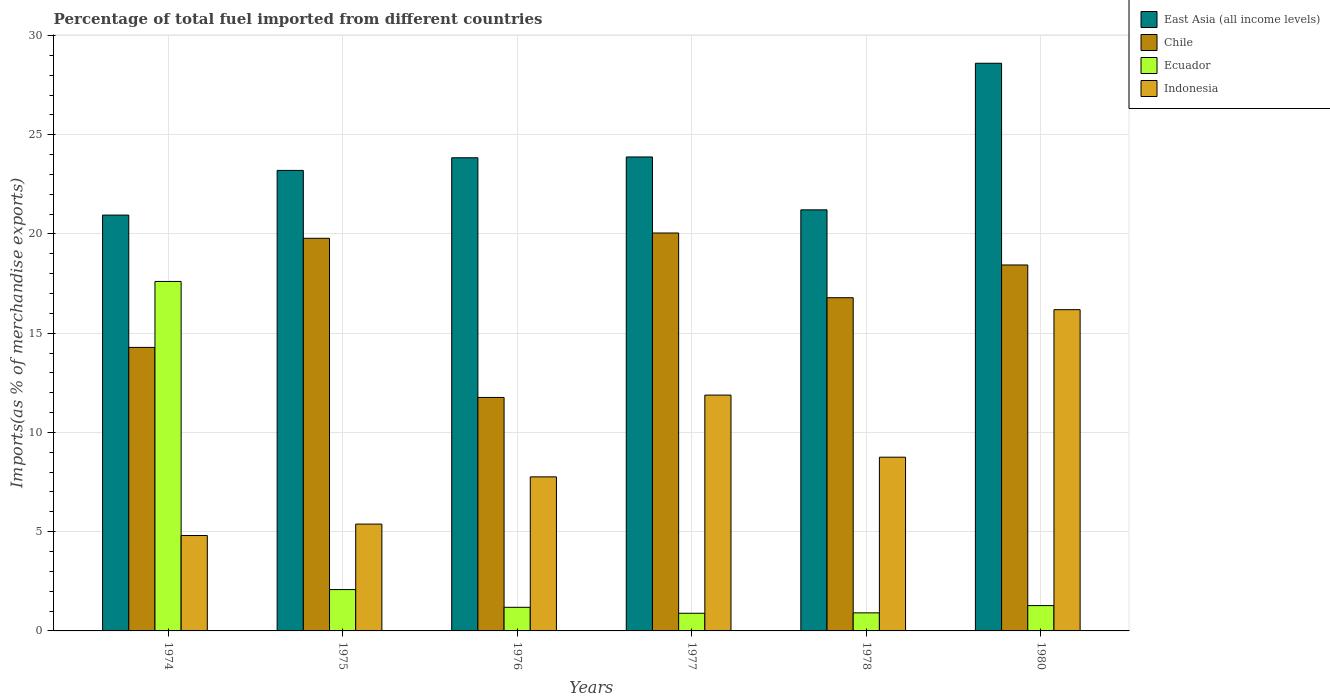How many different coloured bars are there?
Your answer should be compact. 4. Are the number of bars on each tick of the X-axis equal?
Provide a short and direct response. Yes. What is the label of the 2nd group of bars from the left?
Provide a short and direct response. 1975. What is the percentage of imports to different countries in Ecuador in 1975?
Your answer should be very brief. 2.08. Across all years, what is the maximum percentage of imports to different countries in Ecuador?
Provide a short and direct response. 17.61. Across all years, what is the minimum percentage of imports to different countries in Chile?
Your response must be concise. 11.76. What is the total percentage of imports to different countries in Ecuador in the graph?
Keep it short and to the point. 23.96. What is the difference between the percentage of imports to different countries in East Asia (all income levels) in 1975 and that in 1976?
Keep it short and to the point. -0.64. What is the difference between the percentage of imports to different countries in East Asia (all income levels) in 1977 and the percentage of imports to different countries in Chile in 1980?
Your answer should be very brief. 5.44. What is the average percentage of imports to different countries in Ecuador per year?
Your answer should be compact. 3.99. In the year 1978, what is the difference between the percentage of imports to different countries in Indonesia and percentage of imports to different countries in East Asia (all income levels)?
Make the answer very short. -12.46. In how many years, is the percentage of imports to different countries in Indonesia greater than 1 %?
Provide a succinct answer. 6. What is the ratio of the percentage of imports to different countries in Chile in 1976 to that in 1980?
Provide a short and direct response. 0.64. What is the difference between the highest and the second highest percentage of imports to different countries in Indonesia?
Your answer should be compact. 4.3. What is the difference between the highest and the lowest percentage of imports to different countries in Ecuador?
Make the answer very short. 16.72. Is the sum of the percentage of imports to different countries in Chile in 1976 and 1977 greater than the maximum percentage of imports to different countries in Indonesia across all years?
Offer a very short reply. Yes. What does the 2nd bar from the left in 1976 represents?
Ensure brevity in your answer.  Chile. What does the 4th bar from the right in 1976 represents?
Ensure brevity in your answer.  East Asia (all income levels). Are all the bars in the graph horizontal?
Offer a terse response. No. Are the values on the major ticks of Y-axis written in scientific E-notation?
Keep it short and to the point. No. Where does the legend appear in the graph?
Your answer should be very brief. Top right. How are the legend labels stacked?
Your answer should be very brief. Vertical. What is the title of the graph?
Make the answer very short. Percentage of total fuel imported from different countries. What is the label or title of the X-axis?
Your answer should be compact. Years. What is the label or title of the Y-axis?
Your answer should be compact. Imports(as % of merchandise exports). What is the Imports(as % of merchandise exports) of East Asia (all income levels) in 1974?
Give a very brief answer. 20.95. What is the Imports(as % of merchandise exports) in Chile in 1974?
Ensure brevity in your answer.  14.29. What is the Imports(as % of merchandise exports) of Ecuador in 1974?
Provide a short and direct response. 17.61. What is the Imports(as % of merchandise exports) of Indonesia in 1974?
Give a very brief answer. 4.81. What is the Imports(as % of merchandise exports) in East Asia (all income levels) in 1975?
Provide a short and direct response. 23.2. What is the Imports(as % of merchandise exports) of Chile in 1975?
Provide a short and direct response. 19.78. What is the Imports(as % of merchandise exports) of Ecuador in 1975?
Make the answer very short. 2.08. What is the Imports(as % of merchandise exports) in Indonesia in 1975?
Keep it short and to the point. 5.38. What is the Imports(as % of merchandise exports) in East Asia (all income levels) in 1976?
Make the answer very short. 23.84. What is the Imports(as % of merchandise exports) of Chile in 1976?
Ensure brevity in your answer.  11.76. What is the Imports(as % of merchandise exports) in Ecuador in 1976?
Your response must be concise. 1.19. What is the Imports(as % of merchandise exports) of Indonesia in 1976?
Provide a short and direct response. 7.76. What is the Imports(as % of merchandise exports) in East Asia (all income levels) in 1977?
Keep it short and to the point. 23.88. What is the Imports(as % of merchandise exports) in Chile in 1977?
Your answer should be very brief. 20.05. What is the Imports(as % of merchandise exports) of Ecuador in 1977?
Ensure brevity in your answer.  0.89. What is the Imports(as % of merchandise exports) in Indonesia in 1977?
Offer a terse response. 11.88. What is the Imports(as % of merchandise exports) in East Asia (all income levels) in 1978?
Keep it short and to the point. 21.22. What is the Imports(as % of merchandise exports) of Chile in 1978?
Provide a succinct answer. 16.79. What is the Imports(as % of merchandise exports) in Ecuador in 1978?
Your answer should be compact. 0.91. What is the Imports(as % of merchandise exports) of Indonesia in 1978?
Offer a very short reply. 8.75. What is the Imports(as % of merchandise exports) of East Asia (all income levels) in 1980?
Ensure brevity in your answer.  28.6. What is the Imports(as % of merchandise exports) of Chile in 1980?
Offer a terse response. 18.44. What is the Imports(as % of merchandise exports) in Ecuador in 1980?
Provide a succinct answer. 1.28. What is the Imports(as % of merchandise exports) in Indonesia in 1980?
Provide a succinct answer. 16.19. Across all years, what is the maximum Imports(as % of merchandise exports) of East Asia (all income levels)?
Provide a succinct answer. 28.6. Across all years, what is the maximum Imports(as % of merchandise exports) in Chile?
Keep it short and to the point. 20.05. Across all years, what is the maximum Imports(as % of merchandise exports) of Ecuador?
Make the answer very short. 17.61. Across all years, what is the maximum Imports(as % of merchandise exports) of Indonesia?
Offer a very short reply. 16.19. Across all years, what is the minimum Imports(as % of merchandise exports) in East Asia (all income levels)?
Give a very brief answer. 20.95. Across all years, what is the minimum Imports(as % of merchandise exports) in Chile?
Make the answer very short. 11.76. Across all years, what is the minimum Imports(as % of merchandise exports) in Ecuador?
Make the answer very short. 0.89. Across all years, what is the minimum Imports(as % of merchandise exports) in Indonesia?
Keep it short and to the point. 4.81. What is the total Imports(as % of merchandise exports) of East Asia (all income levels) in the graph?
Provide a short and direct response. 141.7. What is the total Imports(as % of merchandise exports) of Chile in the graph?
Keep it short and to the point. 101.11. What is the total Imports(as % of merchandise exports) in Ecuador in the graph?
Your answer should be very brief. 23.96. What is the total Imports(as % of merchandise exports) in Indonesia in the graph?
Your response must be concise. 54.78. What is the difference between the Imports(as % of merchandise exports) in East Asia (all income levels) in 1974 and that in 1975?
Provide a succinct answer. -2.25. What is the difference between the Imports(as % of merchandise exports) of Chile in 1974 and that in 1975?
Make the answer very short. -5.5. What is the difference between the Imports(as % of merchandise exports) in Ecuador in 1974 and that in 1975?
Offer a terse response. 15.53. What is the difference between the Imports(as % of merchandise exports) in Indonesia in 1974 and that in 1975?
Keep it short and to the point. -0.58. What is the difference between the Imports(as % of merchandise exports) in East Asia (all income levels) in 1974 and that in 1976?
Give a very brief answer. -2.89. What is the difference between the Imports(as % of merchandise exports) in Chile in 1974 and that in 1976?
Offer a terse response. 2.52. What is the difference between the Imports(as % of merchandise exports) in Ecuador in 1974 and that in 1976?
Ensure brevity in your answer.  16.42. What is the difference between the Imports(as % of merchandise exports) in Indonesia in 1974 and that in 1976?
Make the answer very short. -2.96. What is the difference between the Imports(as % of merchandise exports) of East Asia (all income levels) in 1974 and that in 1977?
Ensure brevity in your answer.  -2.93. What is the difference between the Imports(as % of merchandise exports) in Chile in 1974 and that in 1977?
Your answer should be compact. -5.76. What is the difference between the Imports(as % of merchandise exports) of Ecuador in 1974 and that in 1977?
Keep it short and to the point. 16.72. What is the difference between the Imports(as % of merchandise exports) of Indonesia in 1974 and that in 1977?
Provide a short and direct response. -7.08. What is the difference between the Imports(as % of merchandise exports) in East Asia (all income levels) in 1974 and that in 1978?
Your response must be concise. -0.26. What is the difference between the Imports(as % of merchandise exports) of Chile in 1974 and that in 1978?
Provide a short and direct response. -2.5. What is the difference between the Imports(as % of merchandise exports) in Ecuador in 1974 and that in 1978?
Your response must be concise. 16.7. What is the difference between the Imports(as % of merchandise exports) in Indonesia in 1974 and that in 1978?
Offer a very short reply. -3.95. What is the difference between the Imports(as % of merchandise exports) of East Asia (all income levels) in 1974 and that in 1980?
Your answer should be compact. -7.65. What is the difference between the Imports(as % of merchandise exports) of Chile in 1974 and that in 1980?
Make the answer very short. -4.15. What is the difference between the Imports(as % of merchandise exports) in Ecuador in 1974 and that in 1980?
Keep it short and to the point. 16.33. What is the difference between the Imports(as % of merchandise exports) of Indonesia in 1974 and that in 1980?
Your answer should be compact. -11.38. What is the difference between the Imports(as % of merchandise exports) in East Asia (all income levels) in 1975 and that in 1976?
Offer a terse response. -0.64. What is the difference between the Imports(as % of merchandise exports) of Chile in 1975 and that in 1976?
Your answer should be compact. 8.02. What is the difference between the Imports(as % of merchandise exports) in Ecuador in 1975 and that in 1976?
Keep it short and to the point. 0.89. What is the difference between the Imports(as % of merchandise exports) in Indonesia in 1975 and that in 1976?
Offer a terse response. -2.38. What is the difference between the Imports(as % of merchandise exports) of East Asia (all income levels) in 1975 and that in 1977?
Your response must be concise. -0.68. What is the difference between the Imports(as % of merchandise exports) of Chile in 1975 and that in 1977?
Your response must be concise. -0.27. What is the difference between the Imports(as % of merchandise exports) of Ecuador in 1975 and that in 1977?
Provide a short and direct response. 1.19. What is the difference between the Imports(as % of merchandise exports) in East Asia (all income levels) in 1975 and that in 1978?
Your response must be concise. 1.99. What is the difference between the Imports(as % of merchandise exports) of Chile in 1975 and that in 1978?
Your response must be concise. 2.99. What is the difference between the Imports(as % of merchandise exports) of Ecuador in 1975 and that in 1978?
Keep it short and to the point. 1.17. What is the difference between the Imports(as % of merchandise exports) in Indonesia in 1975 and that in 1978?
Keep it short and to the point. -3.37. What is the difference between the Imports(as % of merchandise exports) in East Asia (all income levels) in 1975 and that in 1980?
Offer a very short reply. -5.4. What is the difference between the Imports(as % of merchandise exports) of Chile in 1975 and that in 1980?
Your response must be concise. 1.34. What is the difference between the Imports(as % of merchandise exports) in Ecuador in 1975 and that in 1980?
Provide a succinct answer. 0.81. What is the difference between the Imports(as % of merchandise exports) of Indonesia in 1975 and that in 1980?
Keep it short and to the point. -10.8. What is the difference between the Imports(as % of merchandise exports) of East Asia (all income levels) in 1976 and that in 1977?
Provide a succinct answer. -0.04. What is the difference between the Imports(as % of merchandise exports) in Chile in 1976 and that in 1977?
Keep it short and to the point. -8.29. What is the difference between the Imports(as % of merchandise exports) in Ecuador in 1976 and that in 1977?
Offer a terse response. 0.3. What is the difference between the Imports(as % of merchandise exports) in Indonesia in 1976 and that in 1977?
Your answer should be compact. -4.12. What is the difference between the Imports(as % of merchandise exports) in East Asia (all income levels) in 1976 and that in 1978?
Your response must be concise. 2.62. What is the difference between the Imports(as % of merchandise exports) in Chile in 1976 and that in 1978?
Keep it short and to the point. -5.03. What is the difference between the Imports(as % of merchandise exports) in Ecuador in 1976 and that in 1978?
Keep it short and to the point. 0.28. What is the difference between the Imports(as % of merchandise exports) of Indonesia in 1976 and that in 1978?
Your response must be concise. -0.99. What is the difference between the Imports(as % of merchandise exports) of East Asia (all income levels) in 1976 and that in 1980?
Offer a very short reply. -4.76. What is the difference between the Imports(as % of merchandise exports) of Chile in 1976 and that in 1980?
Provide a short and direct response. -6.67. What is the difference between the Imports(as % of merchandise exports) in Ecuador in 1976 and that in 1980?
Your answer should be compact. -0.09. What is the difference between the Imports(as % of merchandise exports) of Indonesia in 1976 and that in 1980?
Offer a terse response. -8.42. What is the difference between the Imports(as % of merchandise exports) of East Asia (all income levels) in 1977 and that in 1978?
Your response must be concise. 2.67. What is the difference between the Imports(as % of merchandise exports) in Chile in 1977 and that in 1978?
Your answer should be very brief. 3.26. What is the difference between the Imports(as % of merchandise exports) of Ecuador in 1977 and that in 1978?
Your answer should be compact. -0.02. What is the difference between the Imports(as % of merchandise exports) in Indonesia in 1977 and that in 1978?
Offer a terse response. 3.13. What is the difference between the Imports(as % of merchandise exports) of East Asia (all income levels) in 1977 and that in 1980?
Offer a very short reply. -4.72. What is the difference between the Imports(as % of merchandise exports) of Chile in 1977 and that in 1980?
Offer a very short reply. 1.61. What is the difference between the Imports(as % of merchandise exports) of Ecuador in 1977 and that in 1980?
Provide a succinct answer. -0.39. What is the difference between the Imports(as % of merchandise exports) in Indonesia in 1977 and that in 1980?
Make the answer very short. -4.3. What is the difference between the Imports(as % of merchandise exports) in East Asia (all income levels) in 1978 and that in 1980?
Offer a terse response. -7.39. What is the difference between the Imports(as % of merchandise exports) in Chile in 1978 and that in 1980?
Give a very brief answer. -1.65. What is the difference between the Imports(as % of merchandise exports) of Ecuador in 1978 and that in 1980?
Provide a short and direct response. -0.37. What is the difference between the Imports(as % of merchandise exports) of Indonesia in 1978 and that in 1980?
Your answer should be very brief. -7.43. What is the difference between the Imports(as % of merchandise exports) in East Asia (all income levels) in 1974 and the Imports(as % of merchandise exports) in Chile in 1975?
Give a very brief answer. 1.17. What is the difference between the Imports(as % of merchandise exports) of East Asia (all income levels) in 1974 and the Imports(as % of merchandise exports) of Ecuador in 1975?
Make the answer very short. 18.87. What is the difference between the Imports(as % of merchandise exports) in East Asia (all income levels) in 1974 and the Imports(as % of merchandise exports) in Indonesia in 1975?
Keep it short and to the point. 15.57. What is the difference between the Imports(as % of merchandise exports) of Chile in 1974 and the Imports(as % of merchandise exports) of Ecuador in 1975?
Keep it short and to the point. 12.2. What is the difference between the Imports(as % of merchandise exports) of Chile in 1974 and the Imports(as % of merchandise exports) of Indonesia in 1975?
Your answer should be compact. 8.9. What is the difference between the Imports(as % of merchandise exports) of Ecuador in 1974 and the Imports(as % of merchandise exports) of Indonesia in 1975?
Your answer should be very brief. 12.23. What is the difference between the Imports(as % of merchandise exports) of East Asia (all income levels) in 1974 and the Imports(as % of merchandise exports) of Chile in 1976?
Ensure brevity in your answer.  9.19. What is the difference between the Imports(as % of merchandise exports) of East Asia (all income levels) in 1974 and the Imports(as % of merchandise exports) of Ecuador in 1976?
Make the answer very short. 19.76. What is the difference between the Imports(as % of merchandise exports) in East Asia (all income levels) in 1974 and the Imports(as % of merchandise exports) in Indonesia in 1976?
Offer a very short reply. 13.19. What is the difference between the Imports(as % of merchandise exports) in Chile in 1974 and the Imports(as % of merchandise exports) in Ecuador in 1976?
Your response must be concise. 13.1. What is the difference between the Imports(as % of merchandise exports) of Chile in 1974 and the Imports(as % of merchandise exports) of Indonesia in 1976?
Provide a succinct answer. 6.52. What is the difference between the Imports(as % of merchandise exports) in Ecuador in 1974 and the Imports(as % of merchandise exports) in Indonesia in 1976?
Provide a short and direct response. 9.85. What is the difference between the Imports(as % of merchandise exports) of East Asia (all income levels) in 1974 and the Imports(as % of merchandise exports) of Chile in 1977?
Give a very brief answer. 0.9. What is the difference between the Imports(as % of merchandise exports) in East Asia (all income levels) in 1974 and the Imports(as % of merchandise exports) in Ecuador in 1977?
Offer a terse response. 20.06. What is the difference between the Imports(as % of merchandise exports) of East Asia (all income levels) in 1974 and the Imports(as % of merchandise exports) of Indonesia in 1977?
Give a very brief answer. 9.07. What is the difference between the Imports(as % of merchandise exports) of Chile in 1974 and the Imports(as % of merchandise exports) of Ecuador in 1977?
Offer a very short reply. 13.4. What is the difference between the Imports(as % of merchandise exports) in Chile in 1974 and the Imports(as % of merchandise exports) in Indonesia in 1977?
Your response must be concise. 2.4. What is the difference between the Imports(as % of merchandise exports) of Ecuador in 1974 and the Imports(as % of merchandise exports) of Indonesia in 1977?
Give a very brief answer. 5.73. What is the difference between the Imports(as % of merchandise exports) of East Asia (all income levels) in 1974 and the Imports(as % of merchandise exports) of Chile in 1978?
Keep it short and to the point. 4.16. What is the difference between the Imports(as % of merchandise exports) in East Asia (all income levels) in 1974 and the Imports(as % of merchandise exports) in Ecuador in 1978?
Keep it short and to the point. 20.04. What is the difference between the Imports(as % of merchandise exports) of East Asia (all income levels) in 1974 and the Imports(as % of merchandise exports) of Indonesia in 1978?
Provide a short and direct response. 12.2. What is the difference between the Imports(as % of merchandise exports) in Chile in 1974 and the Imports(as % of merchandise exports) in Ecuador in 1978?
Ensure brevity in your answer.  13.38. What is the difference between the Imports(as % of merchandise exports) of Chile in 1974 and the Imports(as % of merchandise exports) of Indonesia in 1978?
Ensure brevity in your answer.  5.53. What is the difference between the Imports(as % of merchandise exports) in Ecuador in 1974 and the Imports(as % of merchandise exports) in Indonesia in 1978?
Provide a short and direct response. 8.86. What is the difference between the Imports(as % of merchandise exports) in East Asia (all income levels) in 1974 and the Imports(as % of merchandise exports) in Chile in 1980?
Your response must be concise. 2.51. What is the difference between the Imports(as % of merchandise exports) of East Asia (all income levels) in 1974 and the Imports(as % of merchandise exports) of Ecuador in 1980?
Ensure brevity in your answer.  19.68. What is the difference between the Imports(as % of merchandise exports) in East Asia (all income levels) in 1974 and the Imports(as % of merchandise exports) in Indonesia in 1980?
Your answer should be very brief. 4.77. What is the difference between the Imports(as % of merchandise exports) in Chile in 1974 and the Imports(as % of merchandise exports) in Ecuador in 1980?
Offer a very short reply. 13.01. What is the difference between the Imports(as % of merchandise exports) in Chile in 1974 and the Imports(as % of merchandise exports) in Indonesia in 1980?
Your answer should be compact. -1.9. What is the difference between the Imports(as % of merchandise exports) in Ecuador in 1974 and the Imports(as % of merchandise exports) in Indonesia in 1980?
Your answer should be very brief. 1.42. What is the difference between the Imports(as % of merchandise exports) in East Asia (all income levels) in 1975 and the Imports(as % of merchandise exports) in Chile in 1976?
Keep it short and to the point. 11.44. What is the difference between the Imports(as % of merchandise exports) of East Asia (all income levels) in 1975 and the Imports(as % of merchandise exports) of Ecuador in 1976?
Offer a terse response. 22.01. What is the difference between the Imports(as % of merchandise exports) of East Asia (all income levels) in 1975 and the Imports(as % of merchandise exports) of Indonesia in 1976?
Make the answer very short. 15.44. What is the difference between the Imports(as % of merchandise exports) in Chile in 1975 and the Imports(as % of merchandise exports) in Ecuador in 1976?
Give a very brief answer. 18.59. What is the difference between the Imports(as % of merchandise exports) in Chile in 1975 and the Imports(as % of merchandise exports) in Indonesia in 1976?
Offer a terse response. 12.02. What is the difference between the Imports(as % of merchandise exports) in Ecuador in 1975 and the Imports(as % of merchandise exports) in Indonesia in 1976?
Give a very brief answer. -5.68. What is the difference between the Imports(as % of merchandise exports) in East Asia (all income levels) in 1975 and the Imports(as % of merchandise exports) in Chile in 1977?
Offer a very short reply. 3.15. What is the difference between the Imports(as % of merchandise exports) in East Asia (all income levels) in 1975 and the Imports(as % of merchandise exports) in Ecuador in 1977?
Offer a very short reply. 22.31. What is the difference between the Imports(as % of merchandise exports) in East Asia (all income levels) in 1975 and the Imports(as % of merchandise exports) in Indonesia in 1977?
Your answer should be compact. 11.32. What is the difference between the Imports(as % of merchandise exports) of Chile in 1975 and the Imports(as % of merchandise exports) of Ecuador in 1977?
Give a very brief answer. 18.89. What is the difference between the Imports(as % of merchandise exports) in Chile in 1975 and the Imports(as % of merchandise exports) in Indonesia in 1977?
Your answer should be compact. 7.9. What is the difference between the Imports(as % of merchandise exports) in Ecuador in 1975 and the Imports(as % of merchandise exports) in Indonesia in 1977?
Provide a succinct answer. -9.8. What is the difference between the Imports(as % of merchandise exports) in East Asia (all income levels) in 1975 and the Imports(as % of merchandise exports) in Chile in 1978?
Ensure brevity in your answer.  6.41. What is the difference between the Imports(as % of merchandise exports) of East Asia (all income levels) in 1975 and the Imports(as % of merchandise exports) of Ecuador in 1978?
Your answer should be very brief. 22.29. What is the difference between the Imports(as % of merchandise exports) of East Asia (all income levels) in 1975 and the Imports(as % of merchandise exports) of Indonesia in 1978?
Ensure brevity in your answer.  14.45. What is the difference between the Imports(as % of merchandise exports) of Chile in 1975 and the Imports(as % of merchandise exports) of Ecuador in 1978?
Provide a succinct answer. 18.87. What is the difference between the Imports(as % of merchandise exports) in Chile in 1975 and the Imports(as % of merchandise exports) in Indonesia in 1978?
Offer a very short reply. 11.03. What is the difference between the Imports(as % of merchandise exports) of Ecuador in 1975 and the Imports(as % of merchandise exports) of Indonesia in 1978?
Offer a terse response. -6.67. What is the difference between the Imports(as % of merchandise exports) of East Asia (all income levels) in 1975 and the Imports(as % of merchandise exports) of Chile in 1980?
Offer a very short reply. 4.76. What is the difference between the Imports(as % of merchandise exports) in East Asia (all income levels) in 1975 and the Imports(as % of merchandise exports) in Ecuador in 1980?
Keep it short and to the point. 21.93. What is the difference between the Imports(as % of merchandise exports) in East Asia (all income levels) in 1975 and the Imports(as % of merchandise exports) in Indonesia in 1980?
Offer a very short reply. 7.02. What is the difference between the Imports(as % of merchandise exports) of Chile in 1975 and the Imports(as % of merchandise exports) of Ecuador in 1980?
Your answer should be very brief. 18.51. What is the difference between the Imports(as % of merchandise exports) in Chile in 1975 and the Imports(as % of merchandise exports) in Indonesia in 1980?
Offer a terse response. 3.6. What is the difference between the Imports(as % of merchandise exports) of Ecuador in 1975 and the Imports(as % of merchandise exports) of Indonesia in 1980?
Give a very brief answer. -14.1. What is the difference between the Imports(as % of merchandise exports) in East Asia (all income levels) in 1976 and the Imports(as % of merchandise exports) in Chile in 1977?
Provide a short and direct response. 3.79. What is the difference between the Imports(as % of merchandise exports) of East Asia (all income levels) in 1976 and the Imports(as % of merchandise exports) of Ecuador in 1977?
Provide a short and direct response. 22.95. What is the difference between the Imports(as % of merchandise exports) in East Asia (all income levels) in 1976 and the Imports(as % of merchandise exports) in Indonesia in 1977?
Give a very brief answer. 11.96. What is the difference between the Imports(as % of merchandise exports) of Chile in 1976 and the Imports(as % of merchandise exports) of Ecuador in 1977?
Your response must be concise. 10.87. What is the difference between the Imports(as % of merchandise exports) of Chile in 1976 and the Imports(as % of merchandise exports) of Indonesia in 1977?
Keep it short and to the point. -0.12. What is the difference between the Imports(as % of merchandise exports) in Ecuador in 1976 and the Imports(as % of merchandise exports) in Indonesia in 1977?
Provide a succinct answer. -10.69. What is the difference between the Imports(as % of merchandise exports) in East Asia (all income levels) in 1976 and the Imports(as % of merchandise exports) in Chile in 1978?
Your answer should be very brief. 7.05. What is the difference between the Imports(as % of merchandise exports) in East Asia (all income levels) in 1976 and the Imports(as % of merchandise exports) in Ecuador in 1978?
Provide a short and direct response. 22.93. What is the difference between the Imports(as % of merchandise exports) of East Asia (all income levels) in 1976 and the Imports(as % of merchandise exports) of Indonesia in 1978?
Your answer should be compact. 15.09. What is the difference between the Imports(as % of merchandise exports) in Chile in 1976 and the Imports(as % of merchandise exports) in Ecuador in 1978?
Give a very brief answer. 10.85. What is the difference between the Imports(as % of merchandise exports) in Chile in 1976 and the Imports(as % of merchandise exports) in Indonesia in 1978?
Offer a terse response. 3.01. What is the difference between the Imports(as % of merchandise exports) in Ecuador in 1976 and the Imports(as % of merchandise exports) in Indonesia in 1978?
Keep it short and to the point. -7.56. What is the difference between the Imports(as % of merchandise exports) of East Asia (all income levels) in 1976 and the Imports(as % of merchandise exports) of Chile in 1980?
Keep it short and to the point. 5.4. What is the difference between the Imports(as % of merchandise exports) in East Asia (all income levels) in 1976 and the Imports(as % of merchandise exports) in Ecuador in 1980?
Keep it short and to the point. 22.56. What is the difference between the Imports(as % of merchandise exports) of East Asia (all income levels) in 1976 and the Imports(as % of merchandise exports) of Indonesia in 1980?
Your response must be concise. 7.65. What is the difference between the Imports(as % of merchandise exports) in Chile in 1976 and the Imports(as % of merchandise exports) in Ecuador in 1980?
Offer a terse response. 10.49. What is the difference between the Imports(as % of merchandise exports) in Chile in 1976 and the Imports(as % of merchandise exports) in Indonesia in 1980?
Provide a succinct answer. -4.42. What is the difference between the Imports(as % of merchandise exports) of Ecuador in 1976 and the Imports(as % of merchandise exports) of Indonesia in 1980?
Ensure brevity in your answer.  -15. What is the difference between the Imports(as % of merchandise exports) in East Asia (all income levels) in 1977 and the Imports(as % of merchandise exports) in Chile in 1978?
Provide a succinct answer. 7.09. What is the difference between the Imports(as % of merchandise exports) in East Asia (all income levels) in 1977 and the Imports(as % of merchandise exports) in Ecuador in 1978?
Provide a succinct answer. 22.97. What is the difference between the Imports(as % of merchandise exports) in East Asia (all income levels) in 1977 and the Imports(as % of merchandise exports) in Indonesia in 1978?
Provide a short and direct response. 15.13. What is the difference between the Imports(as % of merchandise exports) of Chile in 1977 and the Imports(as % of merchandise exports) of Ecuador in 1978?
Offer a very short reply. 19.14. What is the difference between the Imports(as % of merchandise exports) of Chile in 1977 and the Imports(as % of merchandise exports) of Indonesia in 1978?
Your answer should be compact. 11.3. What is the difference between the Imports(as % of merchandise exports) in Ecuador in 1977 and the Imports(as % of merchandise exports) in Indonesia in 1978?
Make the answer very short. -7.86. What is the difference between the Imports(as % of merchandise exports) in East Asia (all income levels) in 1977 and the Imports(as % of merchandise exports) in Chile in 1980?
Your answer should be very brief. 5.44. What is the difference between the Imports(as % of merchandise exports) of East Asia (all income levels) in 1977 and the Imports(as % of merchandise exports) of Ecuador in 1980?
Your response must be concise. 22.61. What is the difference between the Imports(as % of merchandise exports) of East Asia (all income levels) in 1977 and the Imports(as % of merchandise exports) of Indonesia in 1980?
Provide a succinct answer. 7.69. What is the difference between the Imports(as % of merchandise exports) of Chile in 1977 and the Imports(as % of merchandise exports) of Ecuador in 1980?
Provide a short and direct response. 18.77. What is the difference between the Imports(as % of merchandise exports) in Chile in 1977 and the Imports(as % of merchandise exports) in Indonesia in 1980?
Make the answer very short. 3.86. What is the difference between the Imports(as % of merchandise exports) in Ecuador in 1977 and the Imports(as % of merchandise exports) in Indonesia in 1980?
Ensure brevity in your answer.  -15.3. What is the difference between the Imports(as % of merchandise exports) in East Asia (all income levels) in 1978 and the Imports(as % of merchandise exports) in Chile in 1980?
Offer a terse response. 2.78. What is the difference between the Imports(as % of merchandise exports) in East Asia (all income levels) in 1978 and the Imports(as % of merchandise exports) in Ecuador in 1980?
Provide a succinct answer. 19.94. What is the difference between the Imports(as % of merchandise exports) of East Asia (all income levels) in 1978 and the Imports(as % of merchandise exports) of Indonesia in 1980?
Your answer should be very brief. 5.03. What is the difference between the Imports(as % of merchandise exports) of Chile in 1978 and the Imports(as % of merchandise exports) of Ecuador in 1980?
Provide a succinct answer. 15.51. What is the difference between the Imports(as % of merchandise exports) in Chile in 1978 and the Imports(as % of merchandise exports) in Indonesia in 1980?
Your response must be concise. 0.6. What is the difference between the Imports(as % of merchandise exports) of Ecuador in 1978 and the Imports(as % of merchandise exports) of Indonesia in 1980?
Offer a terse response. -15.28. What is the average Imports(as % of merchandise exports) in East Asia (all income levels) per year?
Your response must be concise. 23.62. What is the average Imports(as % of merchandise exports) of Chile per year?
Give a very brief answer. 16.85. What is the average Imports(as % of merchandise exports) in Ecuador per year?
Your answer should be very brief. 3.99. What is the average Imports(as % of merchandise exports) of Indonesia per year?
Your answer should be compact. 9.13. In the year 1974, what is the difference between the Imports(as % of merchandise exports) in East Asia (all income levels) and Imports(as % of merchandise exports) in Chile?
Provide a short and direct response. 6.67. In the year 1974, what is the difference between the Imports(as % of merchandise exports) of East Asia (all income levels) and Imports(as % of merchandise exports) of Ecuador?
Ensure brevity in your answer.  3.34. In the year 1974, what is the difference between the Imports(as % of merchandise exports) in East Asia (all income levels) and Imports(as % of merchandise exports) in Indonesia?
Your response must be concise. 16.15. In the year 1974, what is the difference between the Imports(as % of merchandise exports) in Chile and Imports(as % of merchandise exports) in Ecuador?
Offer a terse response. -3.32. In the year 1974, what is the difference between the Imports(as % of merchandise exports) of Chile and Imports(as % of merchandise exports) of Indonesia?
Your answer should be compact. 9.48. In the year 1974, what is the difference between the Imports(as % of merchandise exports) in Ecuador and Imports(as % of merchandise exports) in Indonesia?
Give a very brief answer. 12.8. In the year 1975, what is the difference between the Imports(as % of merchandise exports) in East Asia (all income levels) and Imports(as % of merchandise exports) in Chile?
Your response must be concise. 3.42. In the year 1975, what is the difference between the Imports(as % of merchandise exports) of East Asia (all income levels) and Imports(as % of merchandise exports) of Ecuador?
Offer a very short reply. 21.12. In the year 1975, what is the difference between the Imports(as % of merchandise exports) in East Asia (all income levels) and Imports(as % of merchandise exports) in Indonesia?
Your answer should be compact. 17.82. In the year 1975, what is the difference between the Imports(as % of merchandise exports) of Chile and Imports(as % of merchandise exports) of Ecuador?
Offer a terse response. 17.7. In the year 1975, what is the difference between the Imports(as % of merchandise exports) in Chile and Imports(as % of merchandise exports) in Indonesia?
Keep it short and to the point. 14.4. In the year 1975, what is the difference between the Imports(as % of merchandise exports) of Ecuador and Imports(as % of merchandise exports) of Indonesia?
Your response must be concise. -3.3. In the year 1976, what is the difference between the Imports(as % of merchandise exports) of East Asia (all income levels) and Imports(as % of merchandise exports) of Chile?
Ensure brevity in your answer.  12.08. In the year 1976, what is the difference between the Imports(as % of merchandise exports) in East Asia (all income levels) and Imports(as % of merchandise exports) in Ecuador?
Offer a very short reply. 22.65. In the year 1976, what is the difference between the Imports(as % of merchandise exports) in East Asia (all income levels) and Imports(as % of merchandise exports) in Indonesia?
Provide a short and direct response. 16.08. In the year 1976, what is the difference between the Imports(as % of merchandise exports) of Chile and Imports(as % of merchandise exports) of Ecuador?
Keep it short and to the point. 10.57. In the year 1976, what is the difference between the Imports(as % of merchandise exports) of Chile and Imports(as % of merchandise exports) of Indonesia?
Keep it short and to the point. 4. In the year 1976, what is the difference between the Imports(as % of merchandise exports) of Ecuador and Imports(as % of merchandise exports) of Indonesia?
Provide a succinct answer. -6.57. In the year 1977, what is the difference between the Imports(as % of merchandise exports) of East Asia (all income levels) and Imports(as % of merchandise exports) of Chile?
Provide a short and direct response. 3.83. In the year 1977, what is the difference between the Imports(as % of merchandise exports) in East Asia (all income levels) and Imports(as % of merchandise exports) in Ecuador?
Your response must be concise. 22.99. In the year 1977, what is the difference between the Imports(as % of merchandise exports) of East Asia (all income levels) and Imports(as % of merchandise exports) of Indonesia?
Offer a very short reply. 12. In the year 1977, what is the difference between the Imports(as % of merchandise exports) in Chile and Imports(as % of merchandise exports) in Ecuador?
Ensure brevity in your answer.  19.16. In the year 1977, what is the difference between the Imports(as % of merchandise exports) of Chile and Imports(as % of merchandise exports) of Indonesia?
Keep it short and to the point. 8.17. In the year 1977, what is the difference between the Imports(as % of merchandise exports) of Ecuador and Imports(as % of merchandise exports) of Indonesia?
Your answer should be compact. -10.99. In the year 1978, what is the difference between the Imports(as % of merchandise exports) in East Asia (all income levels) and Imports(as % of merchandise exports) in Chile?
Make the answer very short. 4.43. In the year 1978, what is the difference between the Imports(as % of merchandise exports) of East Asia (all income levels) and Imports(as % of merchandise exports) of Ecuador?
Your response must be concise. 20.31. In the year 1978, what is the difference between the Imports(as % of merchandise exports) in East Asia (all income levels) and Imports(as % of merchandise exports) in Indonesia?
Keep it short and to the point. 12.46. In the year 1978, what is the difference between the Imports(as % of merchandise exports) of Chile and Imports(as % of merchandise exports) of Ecuador?
Give a very brief answer. 15.88. In the year 1978, what is the difference between the Imports(as % of merchandise exports) of Chile and Imports(as % of merchandise exports) of Indonesia?
Make the answer very short. 8.04. In the year 1978, what is the difference between the Imports(as % of merchandise exports) of Ecuador and Imports(as % of merchandise exports) of Indonesia?
Your answer should be compact. -7.84. In the year 1980, what is the difference between the Imports(as % of merchandise exports) of East Asia (all income levels) and Imports(as % of merchandise exports) of Chile?
Make the answer very short. 10.16. In the year 1980, what is the difference between the Imports(as % of merchandise exports) in East Asia (all income levels) and Imports(as % of merchandise exports) in Ecuador?
Provide a succinct answer. 27.33. In the year 1980, what is the difference between the Imports(as % of merchandise exports) of East Asia (all income levels) and Imports(as % of merchandise exports) of Indonesia?
Your answer should be very brief. 12.42. In the year 1980, what is the difference between the Imports(as % of merchandise exports) of Chile and Imports(as % of merchandise exports) of Ecuador?
Offer a terse response. 17.16. In the year 1980, what is the difference between the Imports(as % of merchandise exports) in Chile and Imports(as % of merchandise exports) in Indonesia?
Provide a succinct answer. 2.25. In the year 1980, what is the difference between the Imports(as % of merchandise exports) of Ecuador and Imports(as % of merchandise exports) of Indonesia?
Your answer should be very brief. -14.91. What is the ratio of the Imports(as % of merchandise exports) in East Asia (all income levels) in 1974 to that in 1975?
Offer a very short reply. 0.9. What is the ratio of the Imports(as % of merchandise exports) of Chile in 1974 to that in 1975?
Make the answer very short. 0.72. What is the ratio of the Imports(as % of merchandise exports) of Ecuador in 1974 to that in 1975?
Provide a short and direct response. 8.45. What is the ratio of the Imports(as % of merchandise exports) in Indonesia in 1974 to that in 1975?
Offer a terse response. 0.89. What is the ratio of the Imports(as % of merchandise exports) in East Asia (all income levels) in 1974 to that in 1976?
Your answer should be compact. 0.88. What is the ratio of the Imports(as % of merchandise exports) in Chile in 1974 to that in 1976?
Ensure brevity in your answer.  1.21. What is the ratio of the Imports(as % of merchandise exports) in Ecuador in 1974 to that in 1976?
Offer a terse response. 14.8. What is the ratio of the Imports(as % of merchandise exports) in Indonesia in 1974 to that in 1976?
Your answer should be very brief. 0.62. What is the ratio of the Imports(as % of merchandise exports) of East Asia (all income levels) in 1974 to that in 1977?
Your response must be concise. 0.88. What is the ratio of the Imports(as % of merchandise exports) in Chile in 1974 to that in 1977?
Offer a terse response. 0.71. What is the ratio of the Imports(as % of merchandise exports) of Ecuador in 1974 to that in 1977?
Provide a short and direct response. 19.79. What is the ratio of the Imports(as % of merchandise exports) of Indonesia in 1974 to that in 1977?
Provide a short and direct response. 0.4. What is the ratio of the Imports(as % of merchandise exports) in East Asia (all income levels) in 1974 to that in 1978?
Your answer should be very brief. 0.99. What is the ratio of the Imports(as % of merchandise exports) of Chile in 1974 to that in 1978?
Your answer should be compact. 0.85. What is the ratio of the Imports(as % of merchandise exports) in Ecuador in 1974 to that in 1978?
Your response must be concise. 19.34. What is the ratio of the Imports(as % of merchandise exports) in Indonesia in 1974 to that in 1978?
Give a very brief answer. 0.55. What is the ratio of the Imports(as % of merchandise exports) in East Asia (all income levels) in 1974 to that in 1980?
Ensure brevity in your answer.  0.73. What is the ratio of the Imports(as % of merchandise exports) of Chile in 1974 to that in 1980?
Make the answer very short. 0.77. What is the ratio of the Imports(as % of merchandise exports) in Ecuador in 1974 to that in 1980?
Offer a terse response. 13.79. What is the ratio of the Imports(as % of merchandise exports) in Indonesia in 1974 to that in 1980?
Provide a short and direct response. 0.3. What is the ratio of the Imports(as % of merchandise exports) of East Asia (all income levels) in 1975 to that in 1976?
Give a very brief answer. 0.97. What is the ratio of the Imports(as % of merchandise exports) in Chile in 1975 to that in 1976?
Offer a very short reply. 1.68. What is the ratio of the Imports(as % of merchandise exports) of Ecuador in 1975 to that in 1976?
Offer a very short reply. 1.75. What is the ratio of the Imports(as % of merchandise exports) of Indonesia in 1975 to that in 1976?
Keep it short and to the point. 0.69. What is the ratio of the Imports(as % of merchandise exports) of East Asia (all income levels) in 1975 to that in 1977?
Your answer should be very brief. 0.97. What is the ratio of the Imports(as % of merchandise exports) in Chile in 1975 to that in 1977?
Your answer should be very brief. 0.99. What is the ratio of the Imports(as % of merchandise exports) in Ecuador in 1975 to that in 1977?
Keep it short and to the point. 2.34. What is the ratio of the Imports(as % of merchandise exports) of Indonesia in 1975 to that in 1977?
Keep it short and to the point. 0.45. What is the ratio of the Imports(as % of merchandise exports) in East Asia (all income levels) in 1975 to that in 1978?
Your response must be concise. 1.09. What is the ratio of the Imports(as % of merchandise exports) in Chile in 1975 to that in 1978?
Your response must be concise. 1.18. What is the ratio of the Imports(as % of merchandise exports) of Ecuador in 1975 to that in 1978?
Your answer should be very brief. 2.29. What is the ratio of the Imports(as % of merchandise exports) in Indonesia in 1975 to that in 1978?
Offer a terse response. 0.61. What is the ratio of the Imports(as % of merchandise exports) in East Asia (all income levels) in 1975 to that in 1980?
Ensure brevity in your answer.  0.81. What is the ratio of the Imports(as % of merchandise exports) in Chile in 1975 to that in 1980?
Give a very brief answer. 1.07. What is the ratio of the Imports(as % of merchandise exports) in Ecuador in 1975 to that in 1980?
Provide a succinct answer. 1.63. What is the ratio of the Imports(as % of merchandise exports) of Indonesia in 1975 to that in 1980?
Your response must be concise. 0.33. What is the ratio of the Imports(as % of merchandise exports) in East Asia (all income levels) in 1976 to that in 1977?
Ensure brevity in your answer.  1. What is the ratio of the Imports(as % of merchandise exports) in Chile in 1976 to that in 1977?
Make the answer very short. 0.59. What is the ratio of the Imports(as % of merchandise exports) in Ecuador in 1976 to that in 1977?
Provide a succinct answer. 1.34. What is the ratio of the Imports(as % of merchandise exports) in Indonesia in 1976 to that in 1977?
Keep it short and to the point. 0.65. What is the ratio of the Imports(as % of merchandise exports) of East Asia (all income levels) in 1976 to that in 1978?
Your answer should be very brief. 1.12. What is the ratio of the Imports(as % of merchandise exports) in Chile in 1976 to that in 1978?
Keep it short and to the point. 0.7. What is the ratio of the Imports(as % of merchandise exports) in Ecuador in 1976 to that in 1978?
Give a very brief answer. 1.31. What is the ratio of the Imports(as % of merchandise exports) of Indonesia in 1976 to that in 1978?
Offer a very short reply. 0.89. What is the ratio of the Imports(as % of merchandise exports) of East Asia (all income levels) in 1976 to that in 1980?
Your answer should be compact. 0.83. What is the ratio of the Imports(as % of merchandise exports) in Chile in 1976 to that in 1980?
Keep it short and to the point. 0.64. What is the ratio of the Imports(as % of merchandise exports) of Ecuador in 1976 to that in 1980?
Make the answer very short. 0.93. What is the ratio of the Imports(as % of merchandise exports) in Indonesia in 1976 to that in 1980?
Provide a succinct answer. 0.48. What is the ratio of the Imports(as % of merchandise exports) of East Asia (all income levels) in 1977 to that in 1978?
Offer a terse response. 1.13. What is the ratio of the Imports(as % of merchandise exports) of Chile in 1977 to that in 1978?
Give a very brief answer. 1.19. What is the ratio of the Imports(as % of merchandise exports) in Ecuador in 1977 to that in 1978?
Ensure brevity in your answer.  0.98. What is the ratio of the Imports(as % of merchandise exports) of Indonesia in 1977 to that in 1978?
Your answer should be compact. 1.36. What is the ratio of the Imports(as % of merchandise exports) in East Asia (all income levels) in 1977 to that in 1980?
Your response must be concise. 0.83. What is the ratio of the Imports(as % of merchandise exports) in Chile in 1977 to that in 1980?
Keep it short and to the point. 1.09. What is the ratio of the Imports(as % of merchandise exports) in Ecuador in 1977 to that in 1980?
Offer a very short reply. 0.7. What is the ratio of the Imports(as % of merchandise exports) in Indonesia in 1977 to that in 1980?
Provide a succinct answer. 0.73. What is the ratio of the Imports(as % of merchandise exports) of East Asia (all income levels) in 1978 to that in 1980?
Your answer should be compact. 0.74. What is the ratio of the Imports(as % of merchandise exports) in Chile in 1978 to that in 1980?
Keep it short and to the point. 0.91. What is the ratio of the Imports(as % of merchandise exports) in Ecuador in 1978 to that in 1980?
Offer a terse response. 0.71. What is the ratio of the Imports(as % of merchandise exports) of Indonesia in 1978 to that in 1980?
Offer a very short reply. 0.54. What is the difference between the highest and the second highest Imports(as % of merchandise exports) of East Asia (all income levels)?
Provide a short and direct response. 4.72. What is the difference between the highest and the second highest Imports(as % of merchandise exports) in Chile?
Give a very brief answer. 0.27. What is the difference between the highest and the second highest Imports(as % of merchandise exports) of Ecuador?
Make the answer very short. 15.53. What is the difference between the highest and the second highest Imports(as % of merchandise exports) in Indonesia?
Provide a short and direct response. 4.3. What is the difference between the highest and the lowest Imports(as % of merchandise exports) in East Asia (all income levels)?
Offer a terse response. 7.65. What is the difference between the highest and the lowest Imports(as % of merchandise exports) in Chile?
Your response must be concise. 8.29. What is the difference between the highest and the lowest Imports(as % of merchandise exports) of Ecuador?
Give a very brief answer. 16.72. What is the difference between the highest and the lowest Imports(as % of merchandise exports) in Indonesia?
Provide a short and direct response. 11.38. 